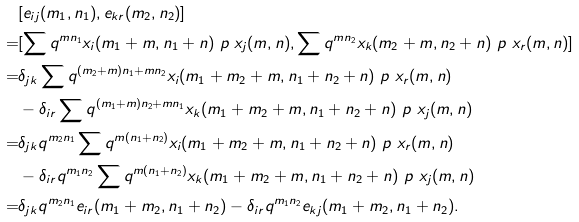<formula> <loc_0><loc_0><loc_500><loc_500>& [ e _ { i j } ( m _ { 1 } , n _ { 1 } ) , e _ { k r } ( m _ { 2 } , n _ { 2 } ) ] \\ = & [ \sum q ^ { m n _ { 1 } } x _ { i } ( m _ { 1 } + m , n _ { 1 } + n ) \ p { \ x _ { j } ( m , n ) } , \sum q ^ { m n _ { 2 } } x _ { k } ( m _ { 2 } + m , n _ { 2 } + n ) \ p { \ x _ { r } ( m , n ) } ] \\ = & \delta _ { j k } \sum q ^ { ( m _ { 2 } + m ) n _ { 1 } + m n _ { 2 } } x _ { i } ( m _ { 1 } + m _ { 2 } + m , n _ { 1 } + n _ { 2 } + n ) \ p { \ x _ { r } ( m , n ) } \\ & - \delta _ { i r } \sum q ^ { ( m _ { 1 } + m ) n _ { 2 } + m n _ { 1 } } x _ { k } ( m _ { 1 } + m _ { 2 } + m , n _ { 1 } + n _ { 2 } + n ) \ p { \ x _ { j } ( m , n ) } \\ = & \delta _ { j k } q ^ { m _ { 2 } n _ { 1 } } \sum q ^ { m ( n _ { 1 } + n _ { 2 } ) } x _ { i } ( m _ { 1 } + m _ { 2 } + m , n _ { 1 } + n _ { 2 } + n ) \ p { \ x _ { r } ( m , n ) } \\ & - \delta _ { i r } q ^ { m _ { 1 } n _ { 2 } } \sum q ^ { m ( n _ { 1 } + n _ { 2 } ) } x _ { k } ( m _ { 1 } + m _ { 2 } + m , n _ { 1 } + n _ { 2 } + n ) \ p { \ x _ { j } ( m , n ) } \\ = & \delta _ { j k } q ^ { m _ { 2 } n _ { 1 } } e _ { i r } ( m _ { 1 } + m _ { 2 } , n _ { 1 } + n _ { 2 } ) - \delta _ { i r } q ^ { m _ { 1 } n _ { 2 } } e _ { k j } ( m _ { 1 } + m _ { 2 } , n _ { 1 } + n _ { 2 } ) .</formula> 